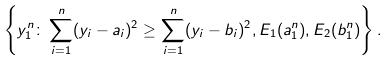<formula> <loc_0><loc_0><loc_500><loc_500>\left \{ y _ { 1 } ^ { n } \colon \sum _ { i = 1 } ^ { n } ( y _ { i } - a _ { i } ) ^ { 2 } \geq \sum _ { i = 1 } ^ { n } ( y _ { i } - b _ { i } ) ^ { 2 } , E _ { 1 } ( a _ { 1 } ^ { n } ) , E _ { 2 } ( b _ { 1 } ^ { n } ) \right \} .</formula> 